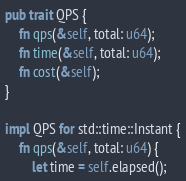<code> <loc_0><loc_0><loc_500><loc_500><_Rust_>pub trait QPS {
    fn qps(&self, total: u64);
    fn time(&self, total: u64);
    fn cost(&self);
}

impl QPS for std::time::Instant {
    fn qps(&self, total: u64) {
        let time = self.elapsed();</code> 